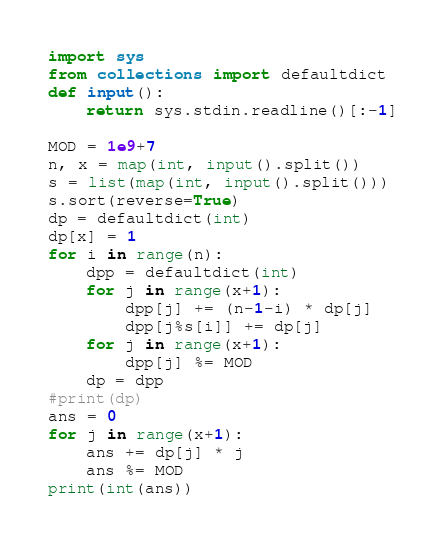Convert code to text. <code><loc_0><loc_0><loc_500><loc_500><_Python_>import sys
from collections import defaultdict
def input():
	return sys.stdin.readline()[:-1]

MOD = 1e9+7
n, x = map(int, input().split())
s = list(map(int, input().split()))
s.sort(reverse=True)
dp = defaultdict(int)
dp[x] = 1
for i in range(n):
	dpp = defaultdict(int)
	for j in range(x+1):
		dpp[j] += (n-1-i) * dp[j]
		dpp[j%s[i]] += dp[j]
	for j in range(x+1):
		dpp[j] %= MOD
	dp = dpp
#print(dp)
ans = 0
for j in range(x+1):
	ans += dp[j] * j
	ans %= MOD
print(int(ans))</code> 